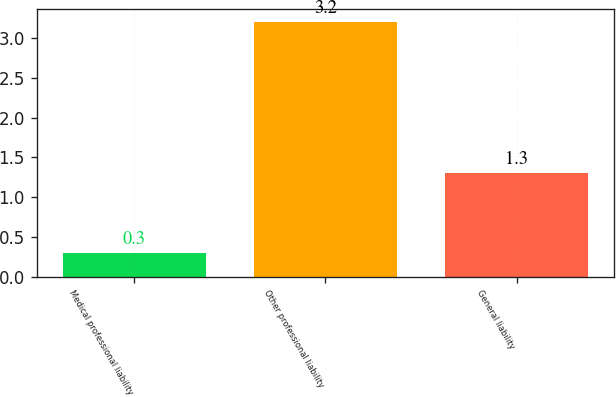Convert chart. <chart><loc_0><loc_0><loc_500><loc_500><bar_chart><fcel>Medical professional liability<fcel>Other professional liability<fcel>General liability<nl><fcel>0.3<fcel>3.2<fcel>1.3<nl></chart> 